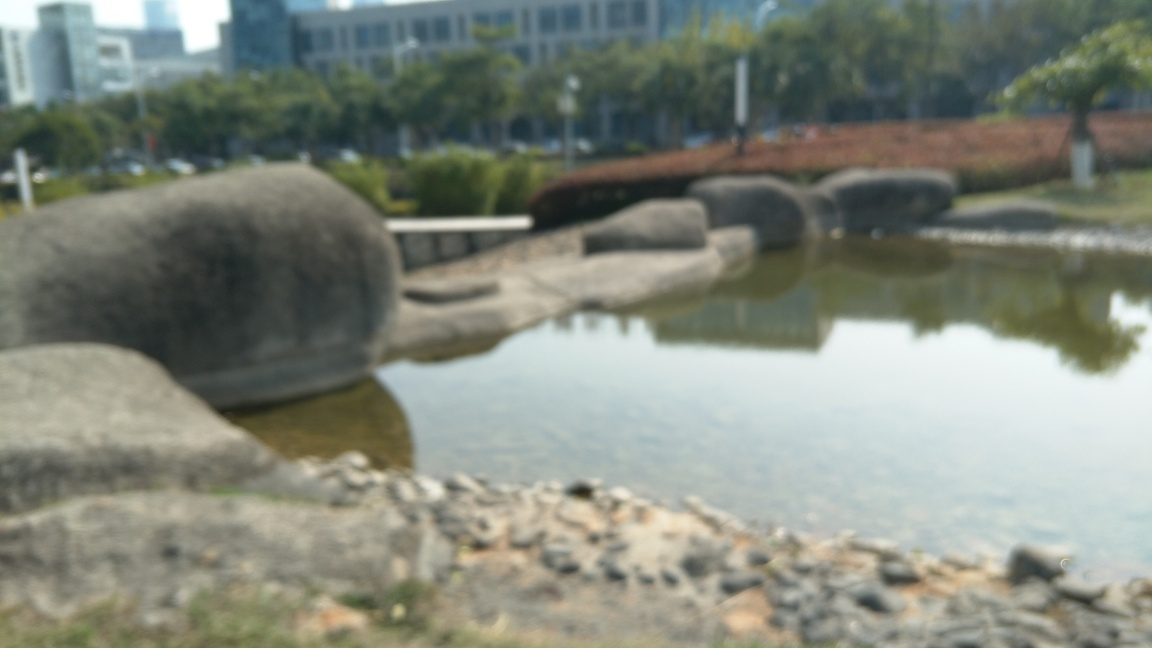Have the main subjects lost most of their texture details? Indeed, it appears that the main subjects in the image have lost most of their texture details due to the blurred focus. The lack of sharpness prevents us from observing the finer details of the textures that might be present on the surfaces, leading to an overall impression that texture detail is missing. This effect is characteristic of a shallow depth of field or a camera lens that is out of focus, often used to create a specific artistic effect or due to a technical mishap during the capturing of the photograph. 